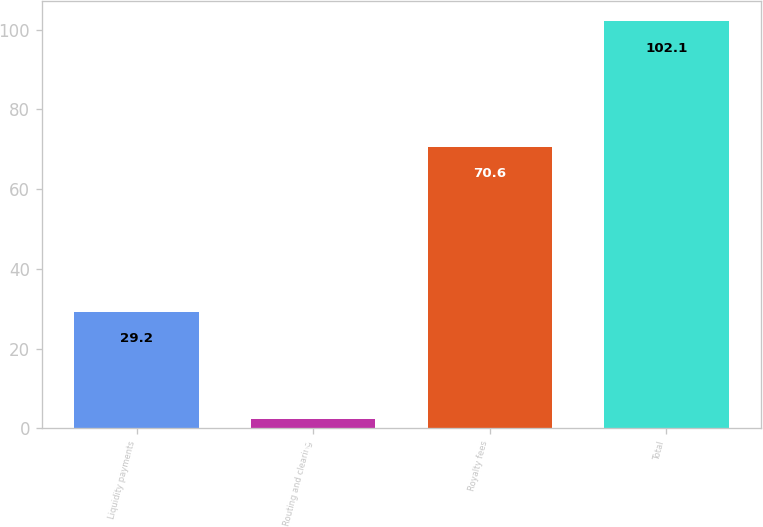Convert chart to OTSL. <chart><loc_0><loc_0><loc_500><loc_500><bar_chart><fcel>Liquidity payments<fcel>Routing and clearing<fcel>Royalty fees<fcel>Total<nl><fcel>29.2<fcel>2.3<fcel>70.6<fcel>102.1<nl></chart> 